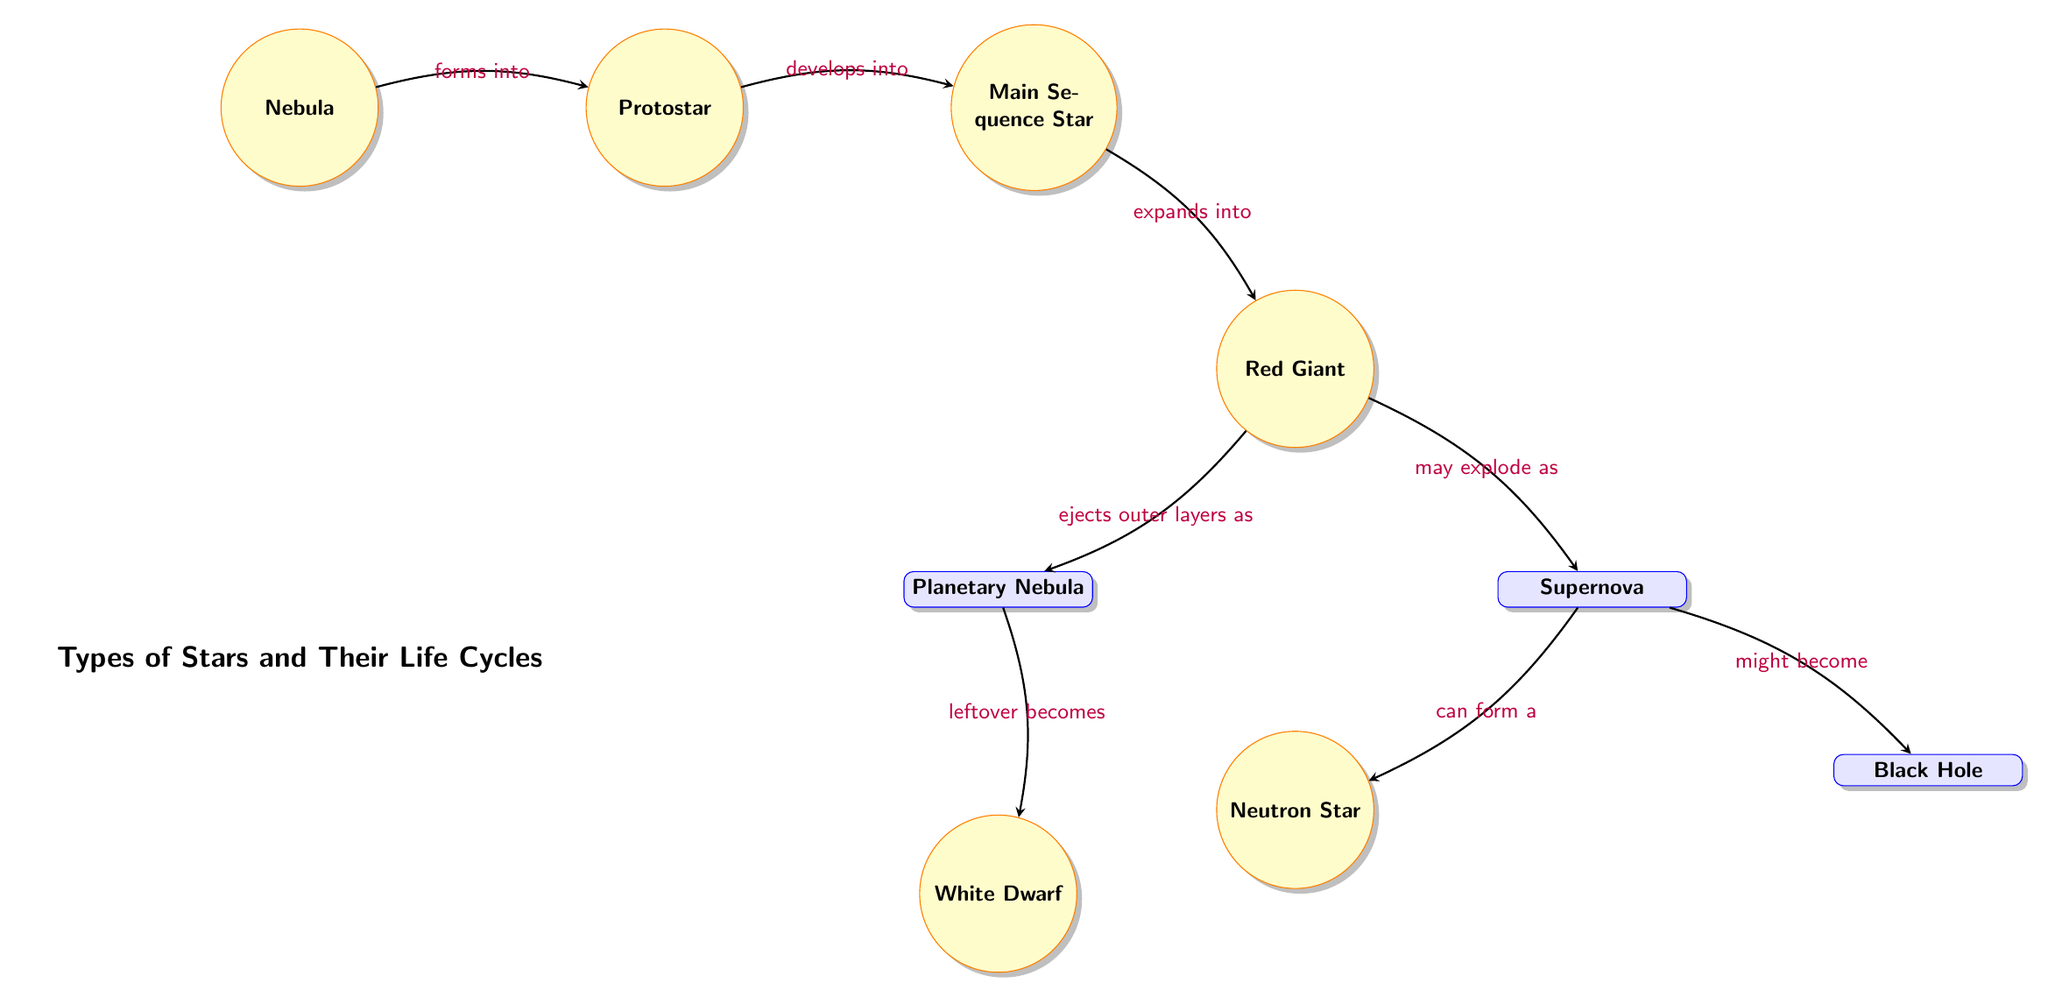What is the first stage in the life cycle of a star? The diagram shows that the first stage in the life cycle of a star is the "Nebula." This is indicated as the starting node from which all other stages develop.
Answer: Nebula How many main phases are identified in the star life cycle? The diagram displays a total of six main nodes representing the phases in the star life cycle: Nebula, Protostar, Main Sequence Star, Red Giant, White Dwarf, Neutron Star, and Black Hole. Counting all these nodes gives us the total number of main phases.
Answer: Six What process leads from the Main Sequence Star to the Red Giant? According to the diagram, a Main Sequence Star "expands into" a Red Giant. This transition is marked by the directional edge between the two nodes.
Answer: Expands into What happens to the outer layers of a Red Giant? The diagram indicates that a Red Giant "ejects outer layers as" a Planetary Nebula. This is a clear relationship shown in the flow from the Red Giant to the Planetary Nebula node.
Answer: Planetary Nebula What can result from a Supernova event? The diagram illustrates that a Supernova can lead to either a Neutron Star or a Black Hole as indicated by the two outgoing edges from the Supernova node. Reasoning through the diagram shows these potential outcomes.
Answer: Neutron Star or Black Hole What are the two possible final stages after a Red Giant explodes? The two possible final stages after a Red Giant explodes are shown as branches from the Supernova node, which can result in either a Neutron Star or a Black Hole, representing the culmination of the diagram's life cycle events.
Answer: Neutron Star and Black Hole How does a Protostar develop? The diagram clarifies that a Protostar "develops into" a Main Sequence Star, indicating the progression from one stage to another. The connection shows that the Protostar is an early development stage leading to a stable star.
Answer: Main Sequence Star What is the leftover remnant after a Planetary Nebula? The diagram specifies that after a Planetary Nebula, the "leftover becomes" a White Dwarf. This indicates a direct transition from the ejected material stage to the dense remnant phase.
Answer: White Dwarf What defines the Main Sequence Star stage in the life cycle? The Main Sequence Star stage is defined in the diagram as a stable period in a star's life cycle, where it is actively fusing hydrogen into helium. This stage precedes the expansion into a Red Giant.
Answer: Stable hydrogen fusion 